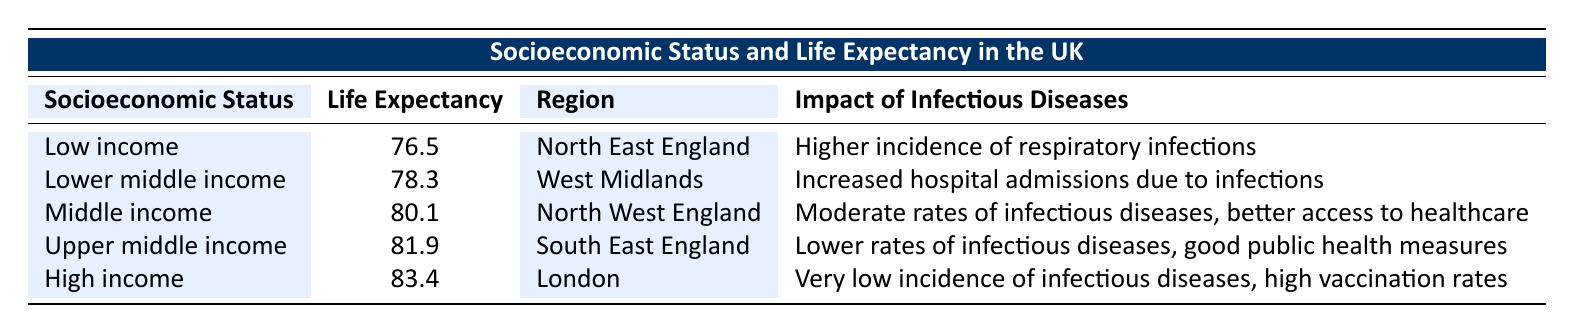What is the life expectancy for individuals with a high income? The table shows that the life expectancy for individuals with a high income is listed under the "Life Expectancy" column. Referring to the row with "High income," we see that the value is 83.4.
Answer: 83.4 In which region do individuals with low income have the shortest life expectancy? By examining the table, we note that the row for "Low income" indicates a life expectancy of 76.5, located in the "North East England" region.
Answer: North East England What is the difference in life expectancy between low income and upper middle income groups? The life expectancy for the low income group is 76.5 and for the upper middle income group is 81.9. To find the difference, we compute 81.9 - 76.5, which equals 5.4.
Answer: 5.4 Is the impact of infectious diseases generally lower for high income individuals compared to those with lower middle income? Looking at the impact of infectious diseases for "High income," it states "Very low incidence of infectious diseases," whereas for "Lower middle income," it says "Increased hospital admissions due to infections." Since "very low" indicates a lesser impact compared to "increased," the statement is true.
Answer: Yes Which socioeconomic status has the highest life expectancy and what is the associated impact of infectious diseases? The table indicates that "High income" has the highest life expectancy of 83.4. The associated impact of infectious diseases is noted as "Very low incidence of infectious diseases, high vaccination rates."
Answer: High income, very low incidence of infectious diseases What is the average life expectancy of individuals in the "Middle income" and "Upper middle income" categories? The life expectancy for "Middle income" is 80.1, and for "Upper middle income," it is 81.9. To calculate the average, we sum these values (80.1 + 81.9 = 162) and divide by 2, resulting in an average of 81.
Answer: 81 Which region experiences a higher incidence of respiratory infections: North East England or West Midlands? The impact of infectious diseases for "North East England" under "Low income" states there is a higher incidence of respiratory infections, while "West Midlands" under "Lower middle income" states there are increased hospital admissions due to infections. Thus, North East England experiences a higher incidence.
Answer: North East England How many socioeconomic statuses listed have a life expectancy greater than 80? Review the life expectancy values from the table. The values above 80 are: 81.9 (Upper middle income) and 83.4 (High income), which gives us 2 qualifying statuses.
Answer: 2 